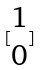<formula> <loc_0><loc_0><loc_500><loc_500>[ \begin{matrix} 1 \\ 0 \end{matrix} ]</formula> 